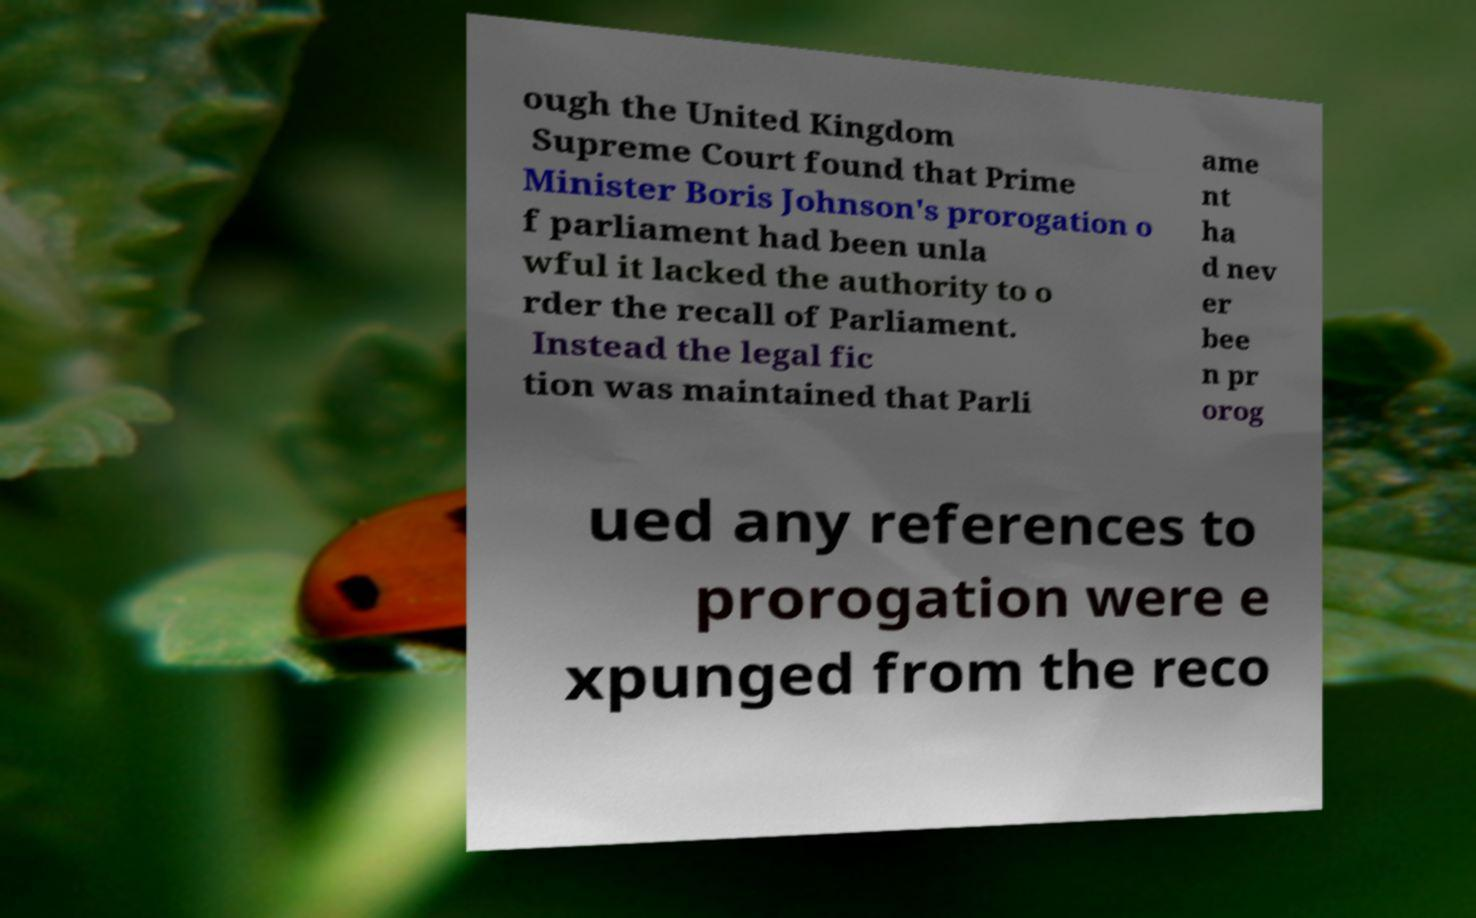There's text embedded in this image that I need extracted. Can you transcribe it verbatim? ough the United Kingdom Supreme Court found that Prime Minister Boris Johnson's prorogation o f parliament had been unla wful it lacked the authority to o rder the recall of Parliament. Instead the legal fic tion was maintained that Parli ame nt ha d nev er bee n pr orog ued any references to prorogation were e xpunged from the reco 